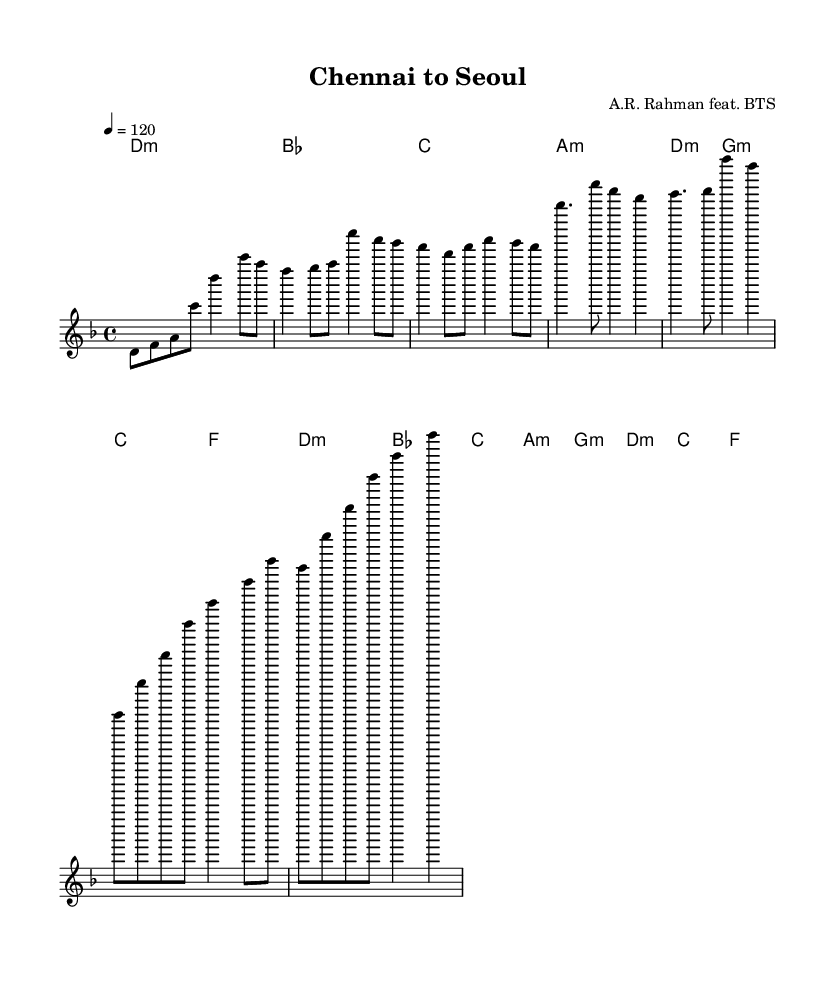what is the key signature of this music? The key signature can be inferred from the global portion of the sheet music where it states "\key d \minor". This indicates that the piece is in the key of D minor, which typically has one flat (B flat).
Answer: D minor what is the time signature of this music? The time signature is indicated in the global section of the sheet music with the notation "\time 4/4". This denotes a common time signature, which means there are four beats in each measure and the quarter note receives one beat.
Answer: 4/4 what is the tempo of this music? The tempo is specified in the global section as "\tempo 4 = 120". This means that the piece should be played at a speed of 120 beats per minute, signifying a moderate pace.
Answer: 120 how many measures are in the chorus section? In the provided melody, the chorus section is indicated by the comments and is made up of two phrases, each consisting of two measures, totaling four measures. A careful count of the notated phrases reveals this structure.
Answer: 4 what is the relationship between A minor and D minor? A minor and D minor are both minor keys. Specifically, A minor is the relative minor of C major, while D minor is the relative minor of F major. They share similar tonal characteristics, but in this piece, A minor serves as a harmonic shift that enhances the overall mood within the D minor context.
Answer: Relative minor which K-Pop group is featured in this collaboration? The composer header states "A.R. Rahman feat. BTS", explicitly mentioning the collaboration with the K-Pop group BTS. This indicates a blend of Western and South Asian musical influences through this collaboration.
Answer: BTS 